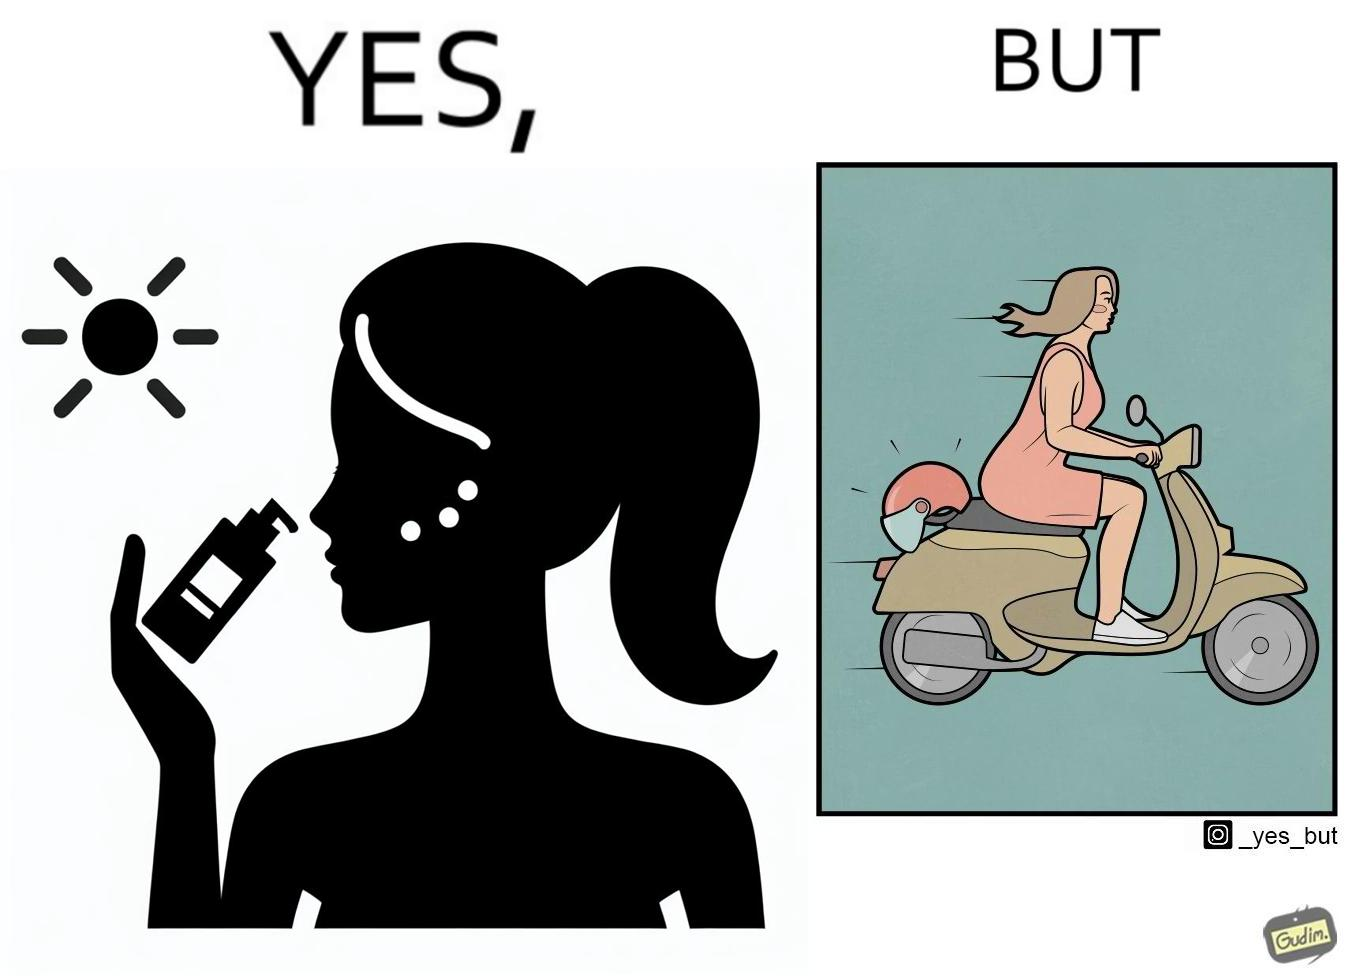Provide a description of this image. The image is funny because while the woman is concerned about protection from the sun rays, she is not concerned about her safety while riding a scooter. 